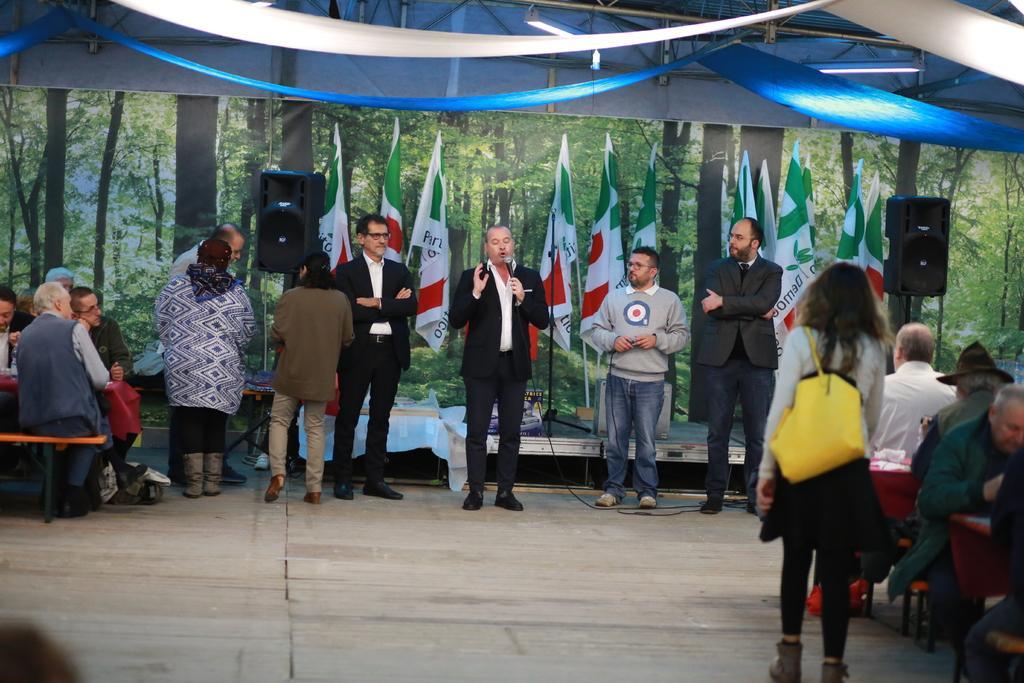How would you summarize this image in a sentence or two? In this image there are group of persons standing and sitting. In the center there is a man standing and speaking and holding a mic. In the background there are flags, speakers, tents and there is a painting on the wall. 